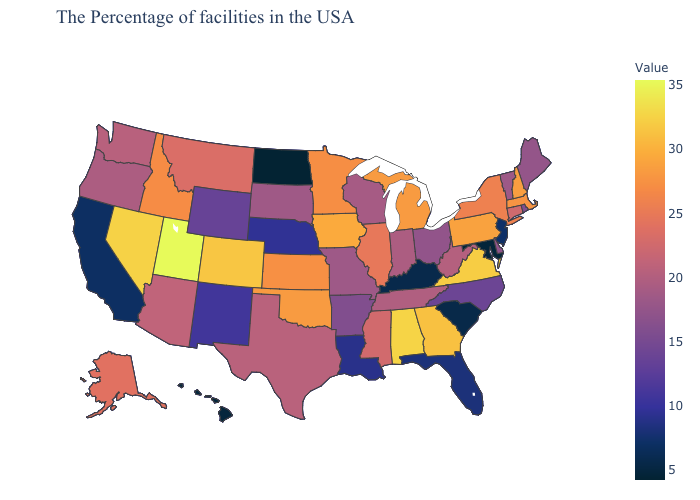Is the legend a continuous bar?
Short answer required. Yes. Does Nebraska have a lower value than Indiana?
Give a very brief answer. Yes. 